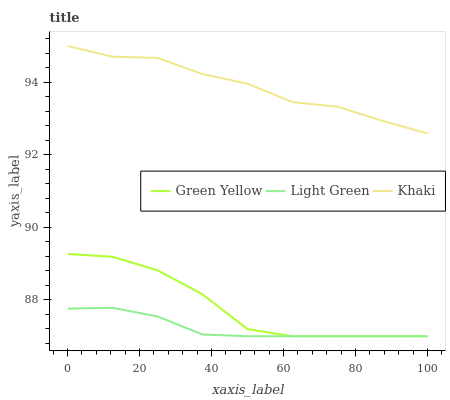Does Khaki have the minimum area under the curve?
Answer yes or no. No. Does Light Green have the maximum area under the curve?
Answer yes or no. No. Is Khaki the smoothest?
Answer yes or no. No. Is Khaki the roughest?
Answer yes or no. No. Does Khaki have the lowest value?
Answer yes or no. No. Does Light Green have the highest value?
Answer yes or no. No. Is Green Yellow less than Khaki?
Answer yes or no. Yes. Is Khaki greater than Light Green?
Answer yes or no. Yes. Does Green Yellow intersect Khaki?
Answer yes or no. No. 